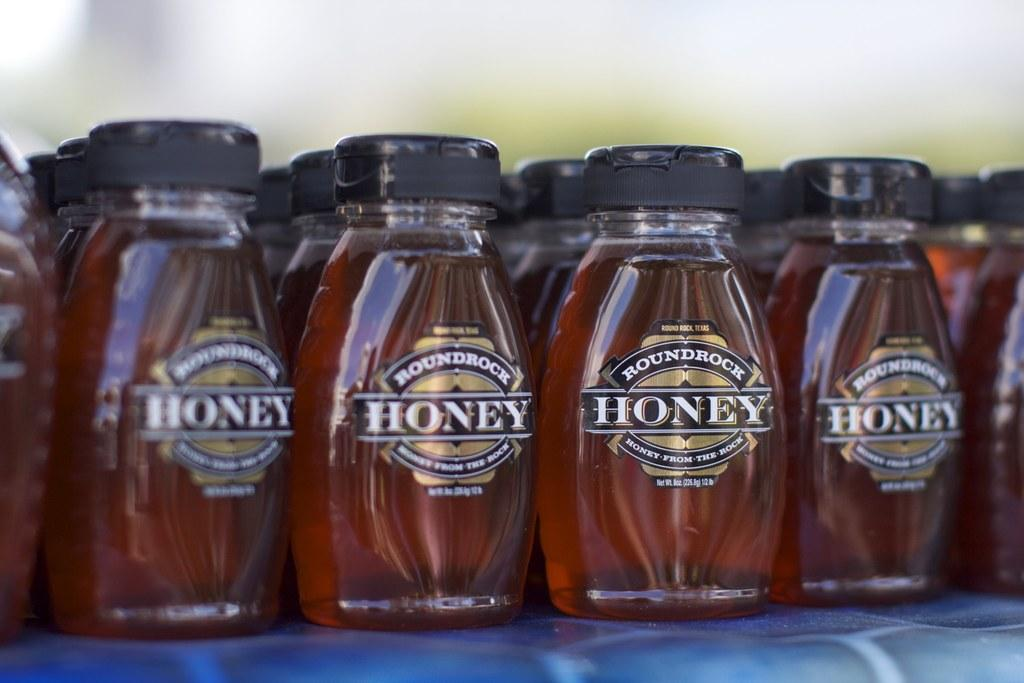What type of containers are present in the image? There are honey bottles in the image. Where are the honey bottles located? The honey bottles are on a table. How many apples are on the table next to the honey bottles? There is no mention of apples in the image, so we cannot determine their presence or quantity. 